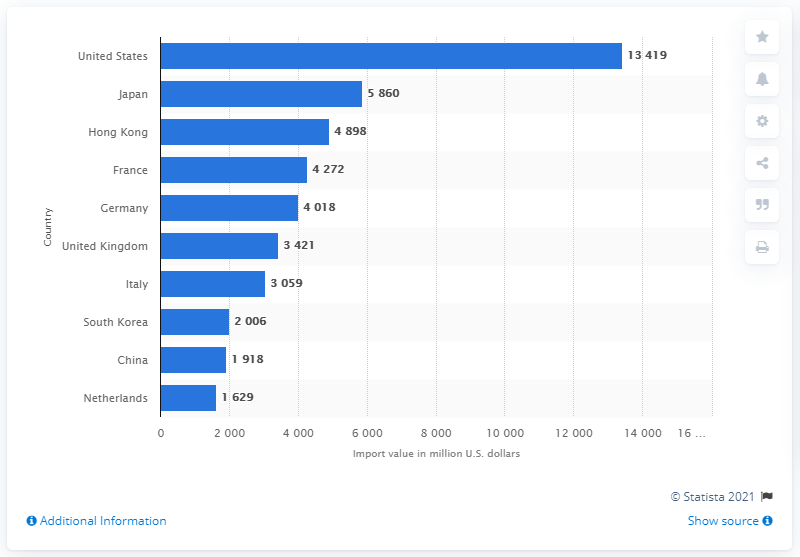Indicate a few pertinent items in this graphic. The import value of leather goods in the United States in 2013 was approximately 13,419. 